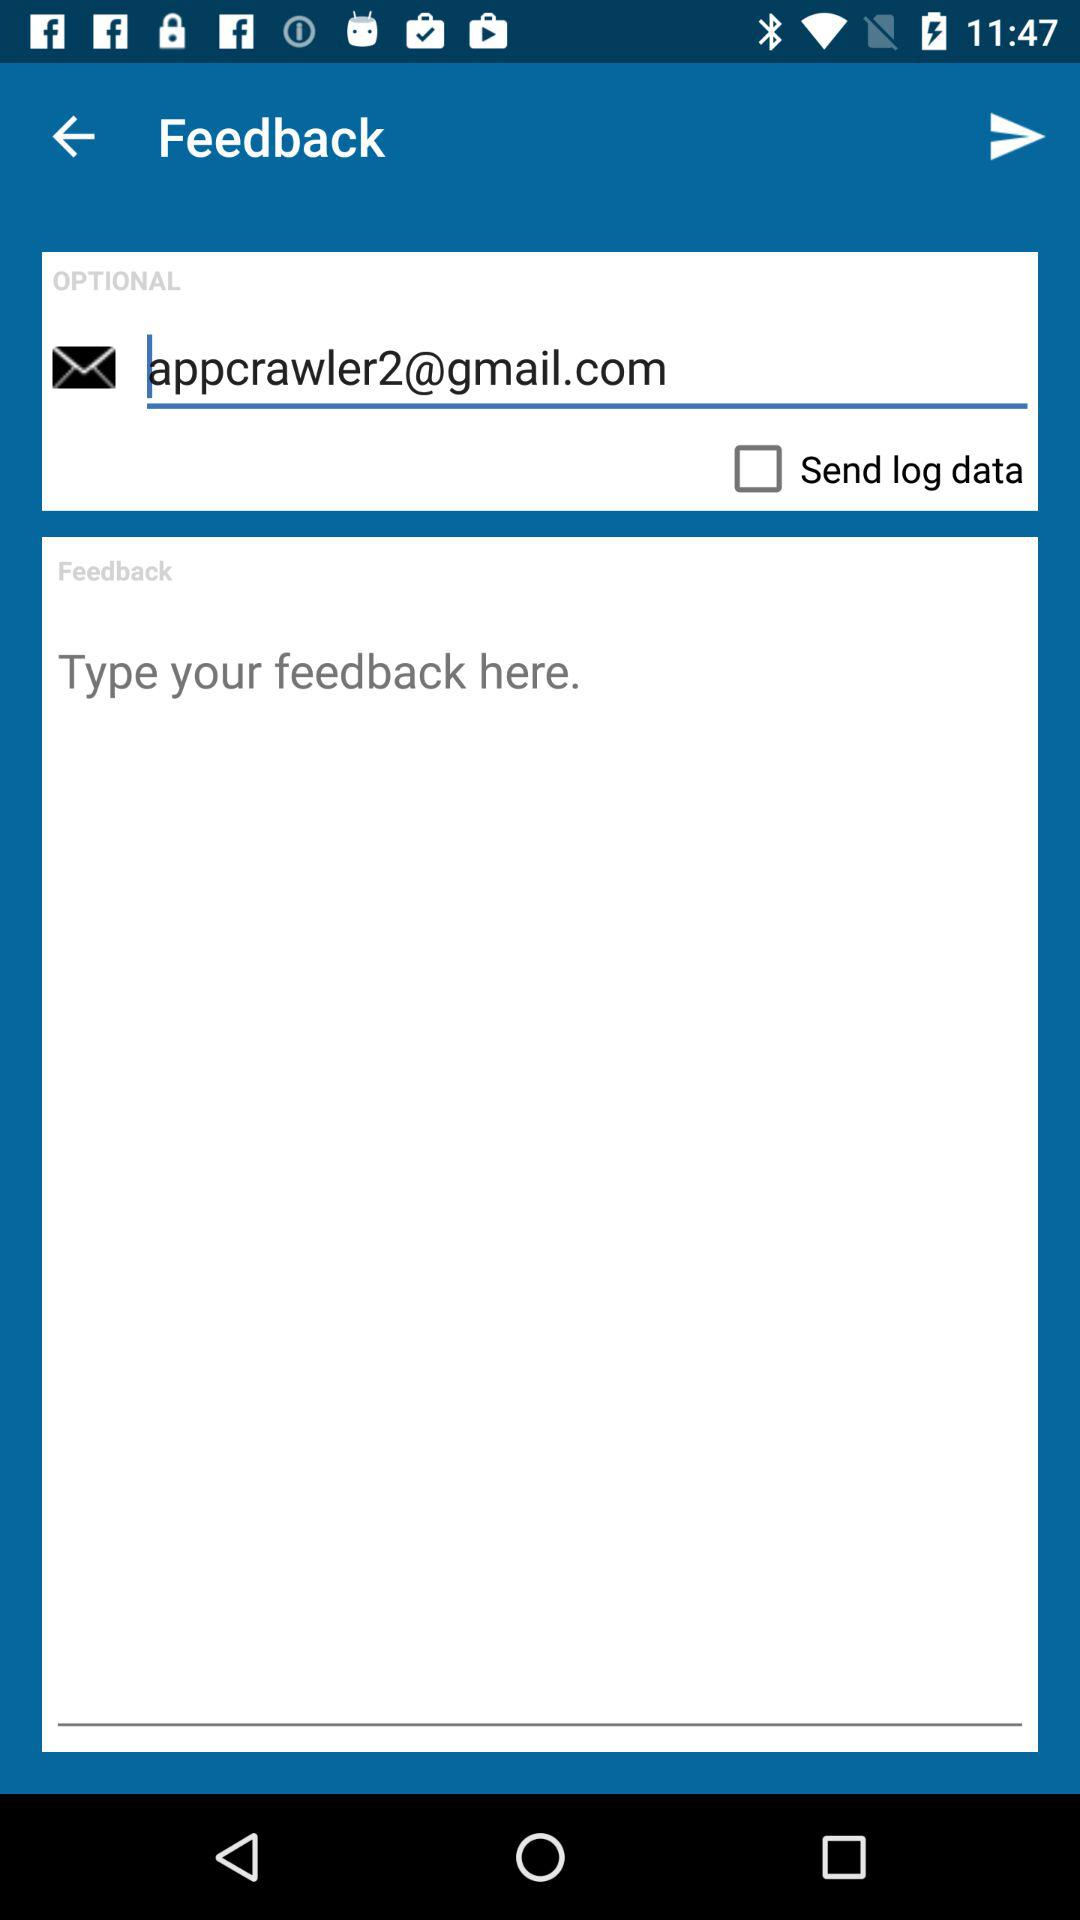What is the email address? The email address is appcrawler2@gmail.com. 